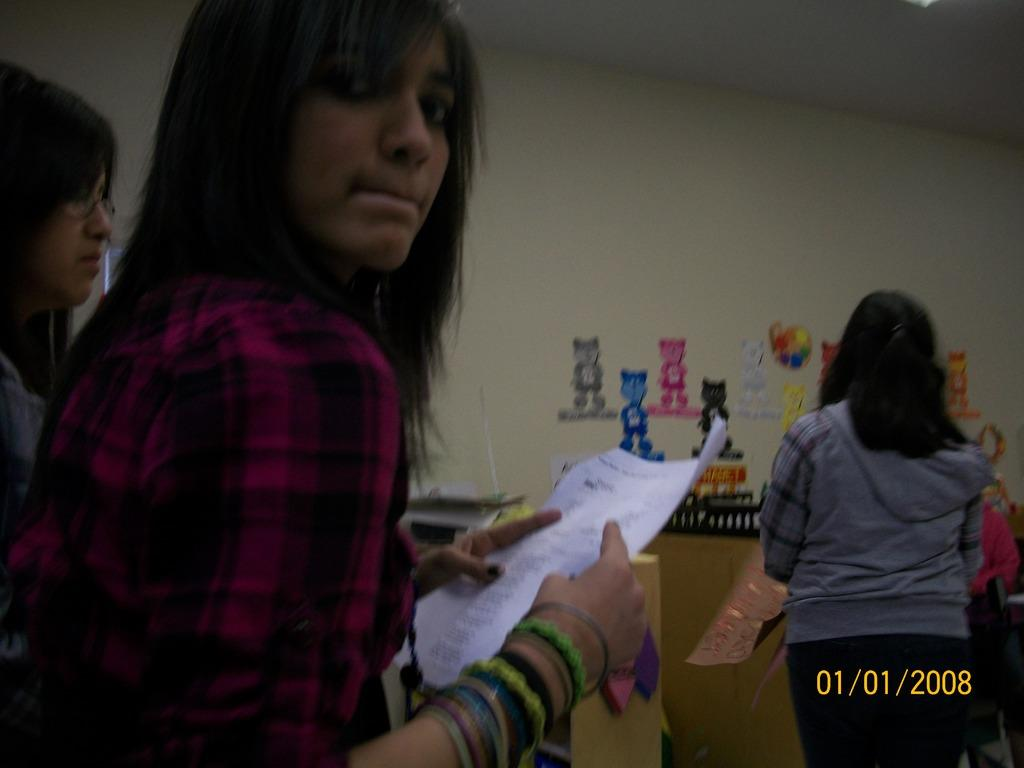<image>
Provide a brief description of the given image. A photograph of a young woman holding a piece of paper in 2008. 